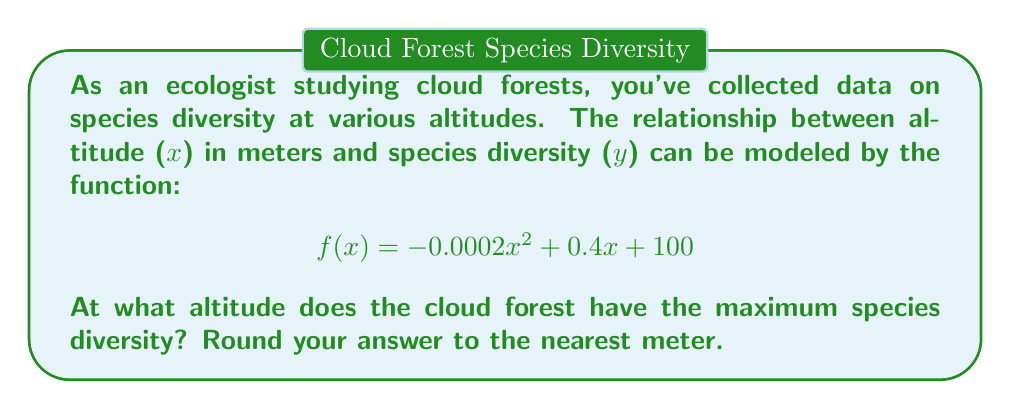Provide a solution to this math problem. To find the altitude with maximum species diversity, we need to find the vertex of the quadratic function. The steps are as follows:

1) The quadratic function is in the form $f(x) = ax^2 + bx + c$, where:
   $a = -0.0002$
   $b = 0.4$
   $c = 100$

2) For a quadratic function, the x-coordinate of the vertex is given by the formula:
   $$x = -\frac{b}{2a}$$

3) Substituting our values:
   $$x = -\frac{0.4}{2(-0.0002)} = \frac{0.4}{0.0004} = 1000$$

4) To verify this is a maximum (not a minimum), we can check that $a < 0$, which it is.

5) The altitude at which maximum species diversity occurs is 1000 meters.

To round to the nearest meter, 1000 remains 1000.
Answer: 1000 meters 